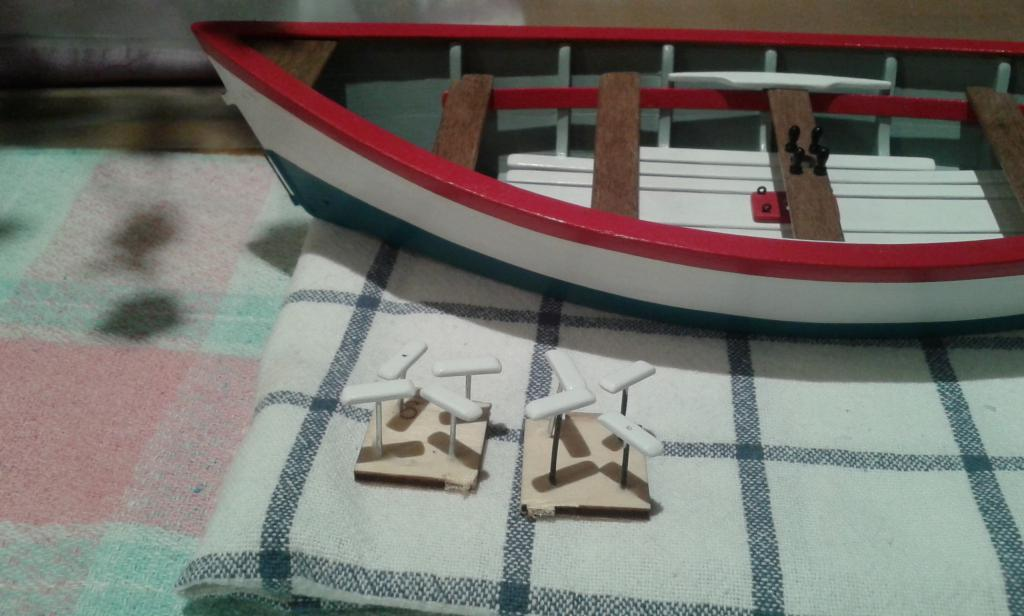What is the main subject of the image? The main subject of the image is a boat. What colors can be seen on the boat? The boat has red, white, and gray colors. How does the boat's aunt react to the shock in the image? There is no aunt or shock present in the image; it only features a boat with red, white, and gray colors. 